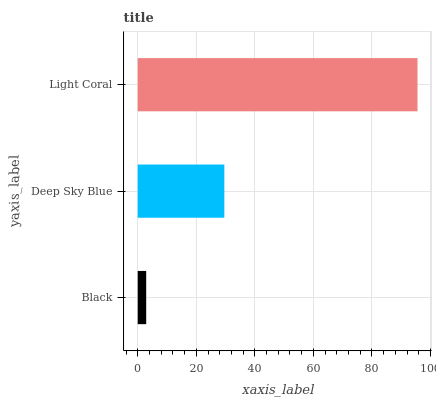Is Black the minimum?
Answer yes or no. Yes. Is Light Coral the maximum?
Answer yes or no. Yes. Is Deep Sky Blue the minimum?
Answer yes or no. No. Is Deep Sky Blue the maximum?
Answer yes or no. No. Is Deep Sky Blue greater than Black?
Answer yes or no. Yes. Is Black less than Deep Sky Blue?
Answer yes or no. Yes. Is Black greater than Deep Sky Blue?
Answer yes or no. No. Is Deep Sky Blue less than Black?
Answer yes or no. No. Is Deep Sky Blue the high median?
Answer yes or no. Yes. Is Deep Sky Blue the low median?
Answer yes or no. Yes. Is Light Coral the high median?
Answer yes or no. No. Is Black the low median?
Answer yes or no. No. 